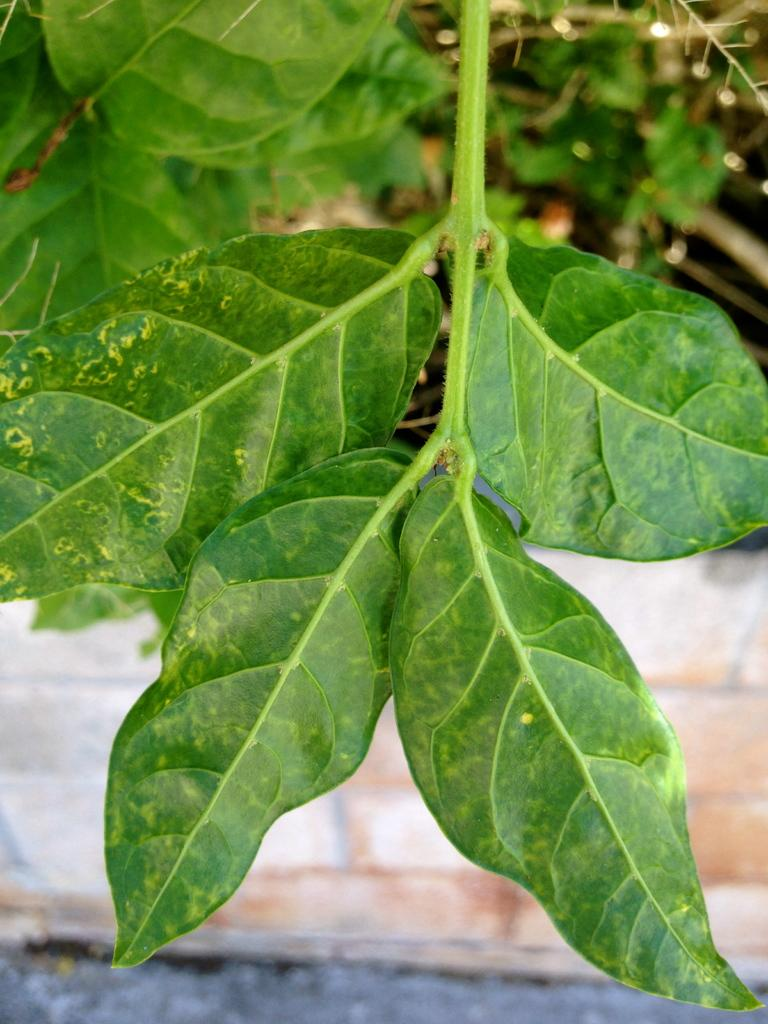What type of plant life is present in the image? The image contains green leaves with stems. What can be seen in the background of the image? There is a wall and a road in the background of the image. Where are the leaves and stems located in the image? Leaves and stems are visible at the top of the image. What type of suit is hanging on the window in the image? There is no suit or window present in the image. 